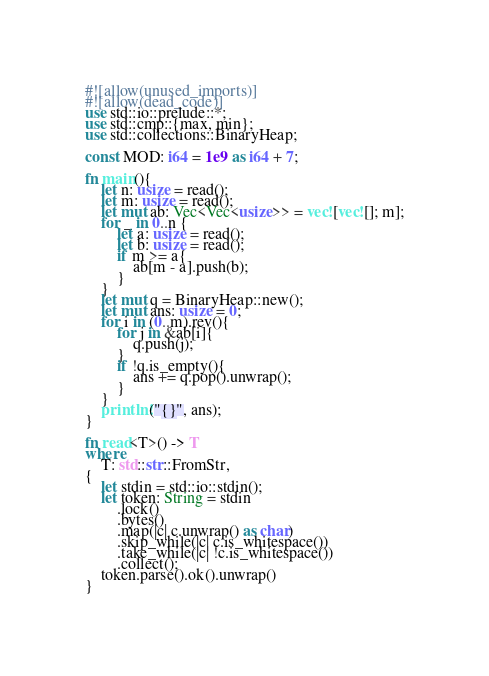Convert code to text. <code><loc_0><loc_0><loc_500><loc_500><_Rust_>#![allow(unused_imports)]
#![allow(dead_code)]
use std::io::prelude::*;
use std::cmp::{max, min};
use std::collections::BinaryHeap;

const MOD: i64 = 1e9 as i64 + 7; 

fn main(){
    let n: usize = read();
    let m: usize = read();
    let mut ab: Vec<Vec<usize>> = vec![vec![]; m];
    for _ in 0..n {
        let a: usize = read();
        let b: usize = read();
        if m >= a{
            ab[m - a].push(b);
        }
    }
    let mut q = BinaryHeap::new();
    let mut ans: usize = 0;
    for i in (0..m).rev(){
        for j in &ab[i]{
            q.push(j);
        }
        if !q.is_empty(){
            ans += q.pop().unwrap();
        }
    } 
    println!("{}", ans);
}

fn read<T>() -> T
where
    T: std::str::FromStr,
{
    let stdin = std::io::stdin();
    let token: String = stdin
        .lock()
        .bytes()
        .map(|c| c.unwrap() as char)
        .skip_while(|c| c.is_whitespace())
        .take_while(|c| !c.is_whitespace())
        .collect();
    token.parse().ok().unwrap()
}
</code> 